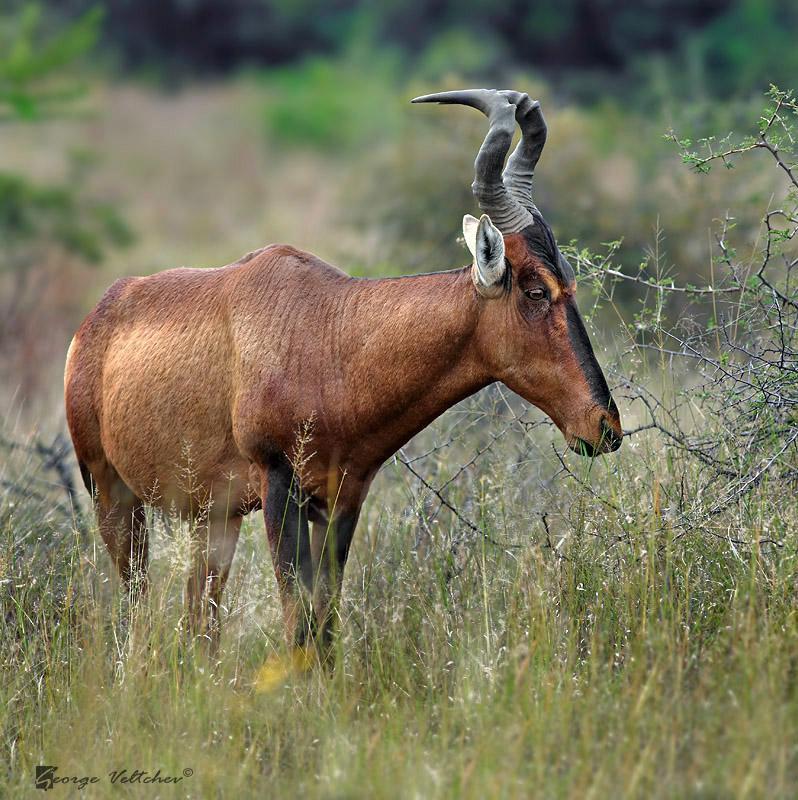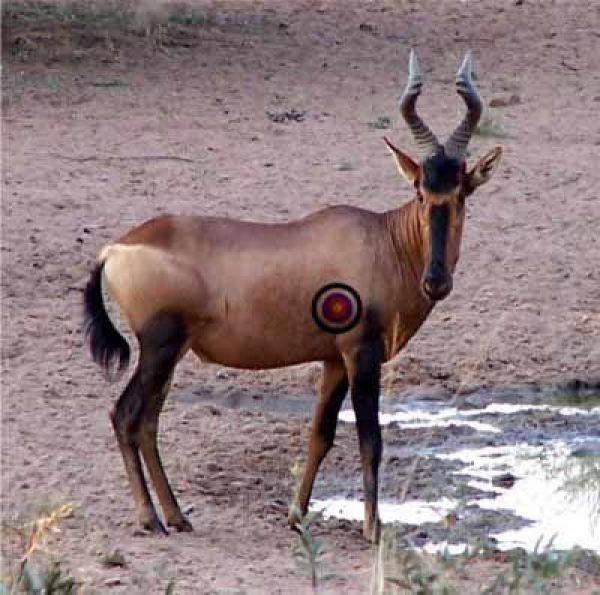The first image is the image on the left, the second image is the image on the right. Considering the images on both sides, is "The animal in the image on the right is lying down." valid? Answer yes or no. No. 